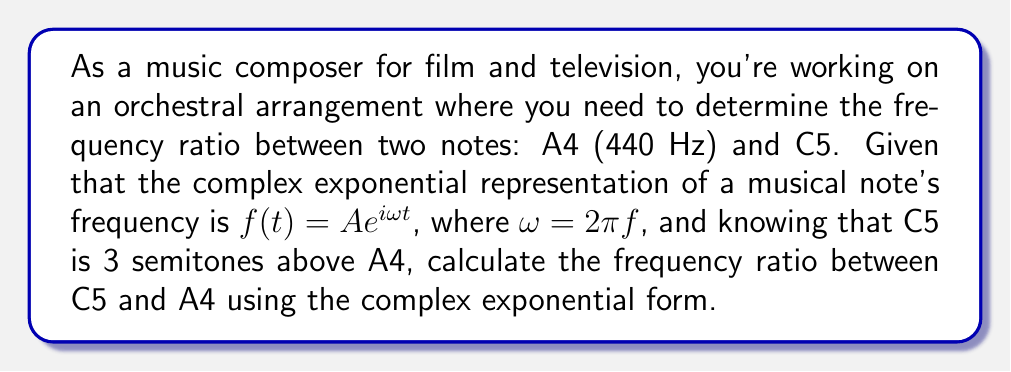Help me with this question. 1. First, recall that the frequency ratio between two adjacent semitones in equal temperament is the twelfth root of 2:
   $$r = \sqrt[12]{2}$$

2. Since C5 is 3 semitones above A4, we need to raise this ratio to the power of 3:
   $$\text{Frequency ratio} = (\sqrt[12]{2})^3$$

3. Now, let's express this using complex exponentials. The general form of a complex exponential for a musical note is:
   $$f(t) = Ae^{i\omega t}$$
   where $\omega = 2\pi f$ and $f$ is the frequency.

4. For A4 (440 Hz):
   $$f_{A4}(t) = Ae^{i2\pi(440)t}$$

5. For C5, we multiply the frequency of A4 by the ratio we found:
   $$f_{C5}(t) = Ae^{i2\pi(440 \cdot (\sqrt[12]{2})^3)t}$$

6. The frequency ratio is the ratio of the angular frequencies:
   $$\text{Ratio} = \frac{\omega_{C5}}{\omega_{A4}} = \frac{2\pi(440 \cdot (\sqrt[12]{2})^3)}{2\pi(440)} = (\sqrt[12]{2})^3$$

7. Calculate the numerical value:
   $$(\sqrt[12]{2})^3 \approx 1.189207115$$
Answer: $(\sqrt[12]{2})^3 \approx 1.189207115$ 